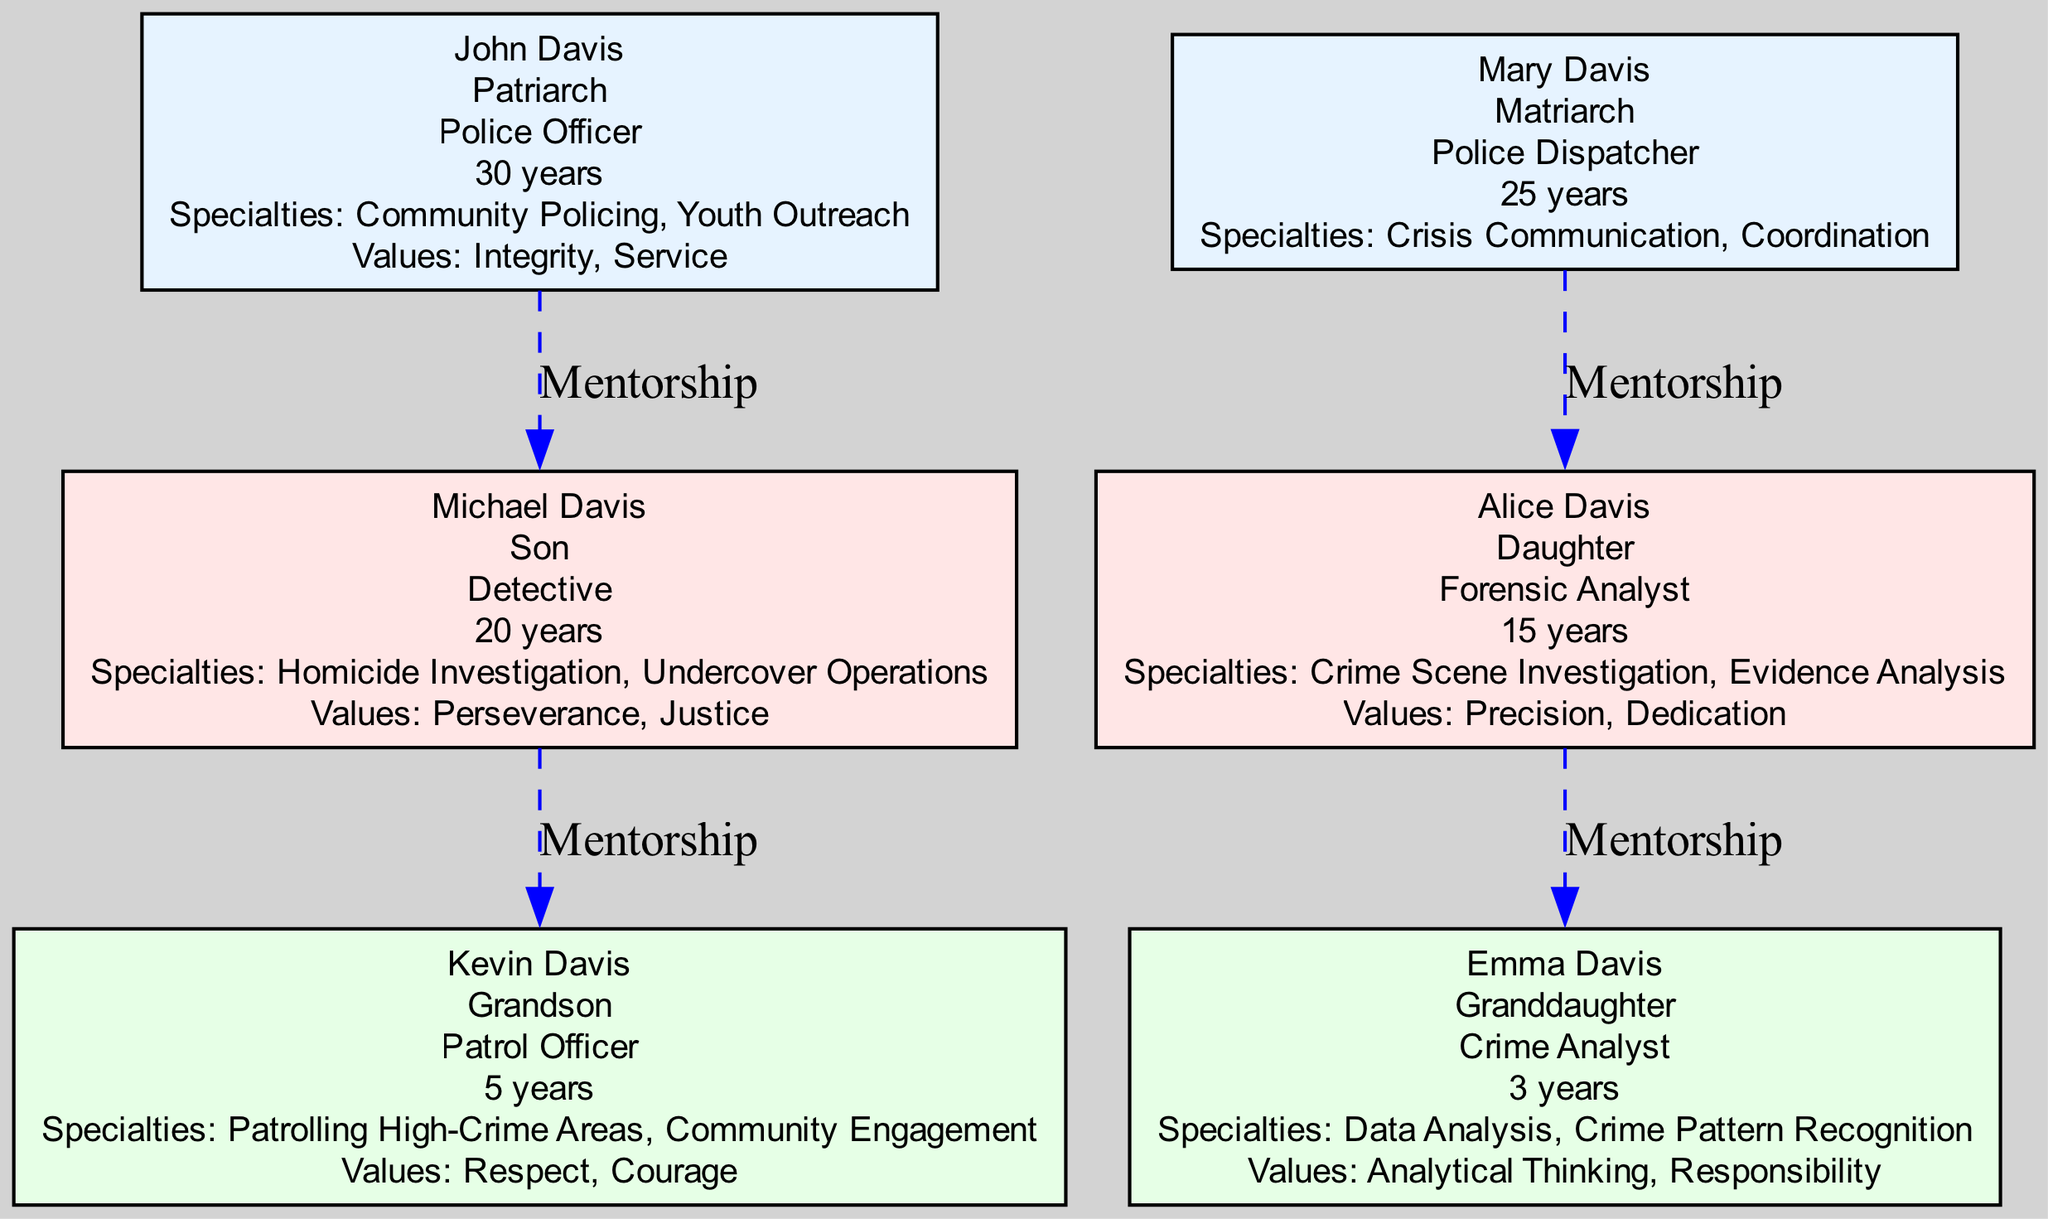What is the career of the Matriarch? The Matriarch in the first generation is Mary Davis, and her career is listed as Police Dispatcher.
Answer: Police Dispatcher How many years of service did John Davis have? John Davis is identified as the Patriarch and has 30 years of service in the police force as indicated in his profile.
Answer: 30 Who mentored Kevin Davis? In the diagram, Kevin Davis is shown as having received mentorship from his father, Michael Davis.
Answer: Michael Davis What values did Alice Davis inherit? Alice Davis, the daughter in the second generation, has values passed down to her, which are Precision and Dedication as mentioned in her section.
Answer: Precision, Dedication Which member specializes in Homicide Investigation? The member specializing in Homicide Investigation is Michael Davis, as stated in his career specialties.
Answer: Michael Davis How many members are in the third generation? The diagram shows that there are two members in the third generation: Kevin Davis and Emma Davis.
Answer: 2 Who is the Granddaughter? The Granddaughter in the family tree is Emma Davis, as mentioned in her profile.
Answer: Emma Davis What role does Kevin Davis hold? According to the diagram, Kevin Davis' role is that of a Patrol Officer, as specified in his details.
Answer: Patrol Officer Which member serves a role in Crisis Communication? Mary Davis, as the Matriarch, specializes in Crisis Communication, according to her career specialties.
Answer: Mary Davis 